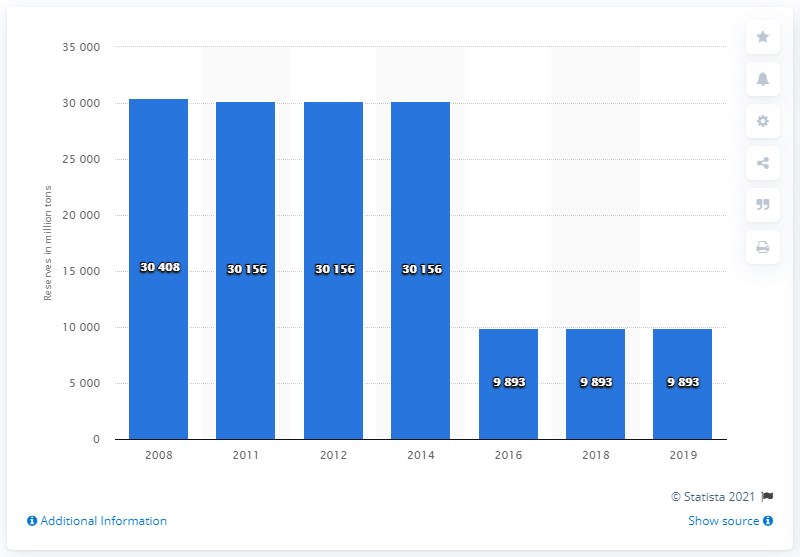Highlight a few significant elements in this photo. The difference between countries with the highest and lowest values can be significant. What is the median value? It is 30156. In 2019, the amount of anthracite and bituminous coal in South Africa was 9,893. 